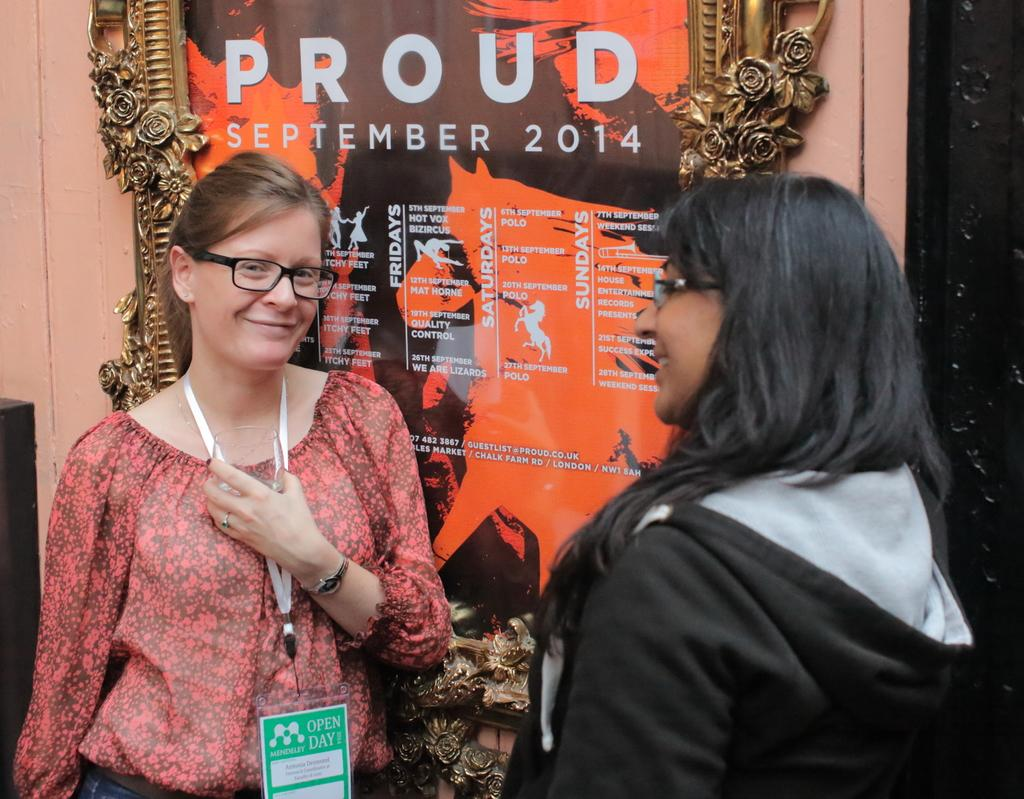How many people are in the image? There are two persons in the image. What are the persons doing in the image? The persons are standing and smiling. What can be seen on the wall in the image? There is a frame on the wall in the image. What is written or depicted on the frame? There is text on the frame. What type of brass instrument is being played by the persons in the image? There is no brass instrument present in the image; the persons are simply standing and smiling. 